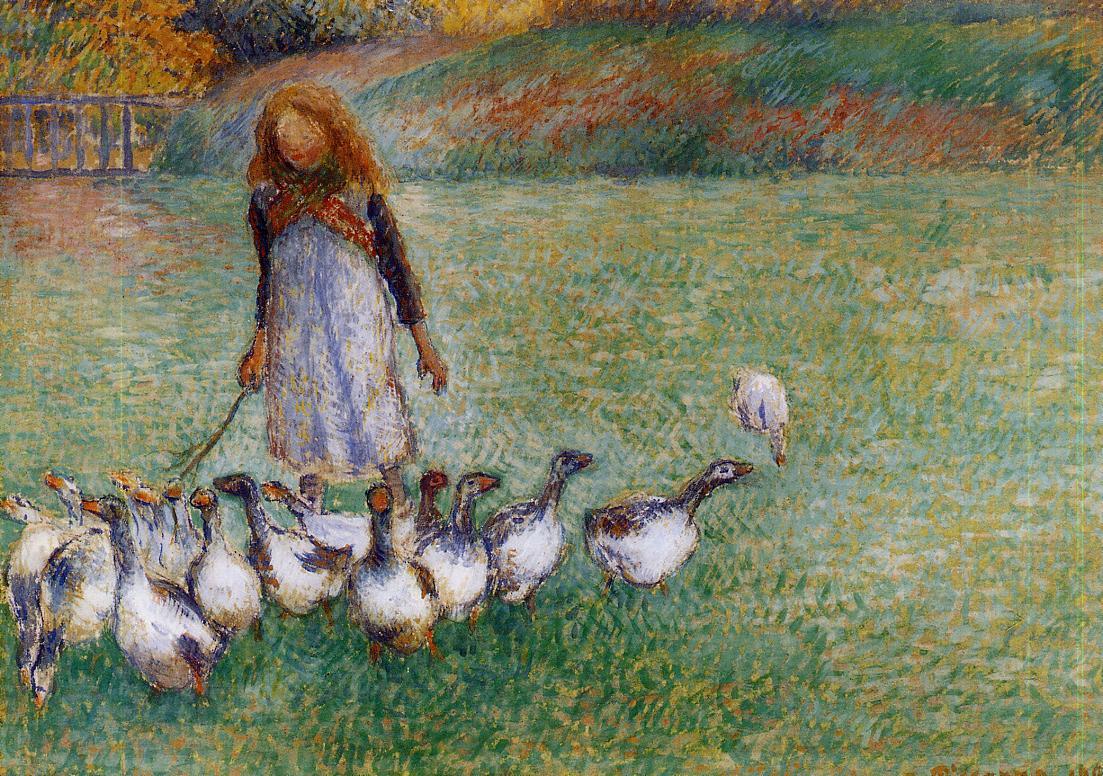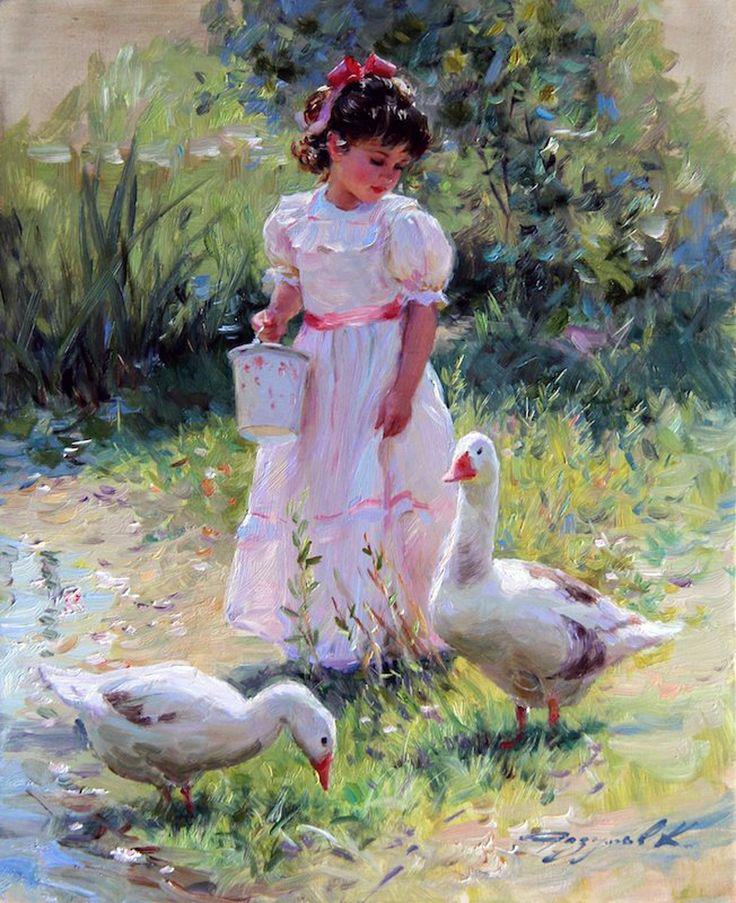The first image is the image on the left, the second image is the image on the right. For the images shown, is this caption "An image contains a goose attacking a child." true? Answer yes or no. No. The first image is the image on the left, the second image is the image on the right. Evaluate the accuracy of this statement regarding the images: "A child is playing outside with a single bird in one of the images.". Is it true? Answer yes or no. No. 